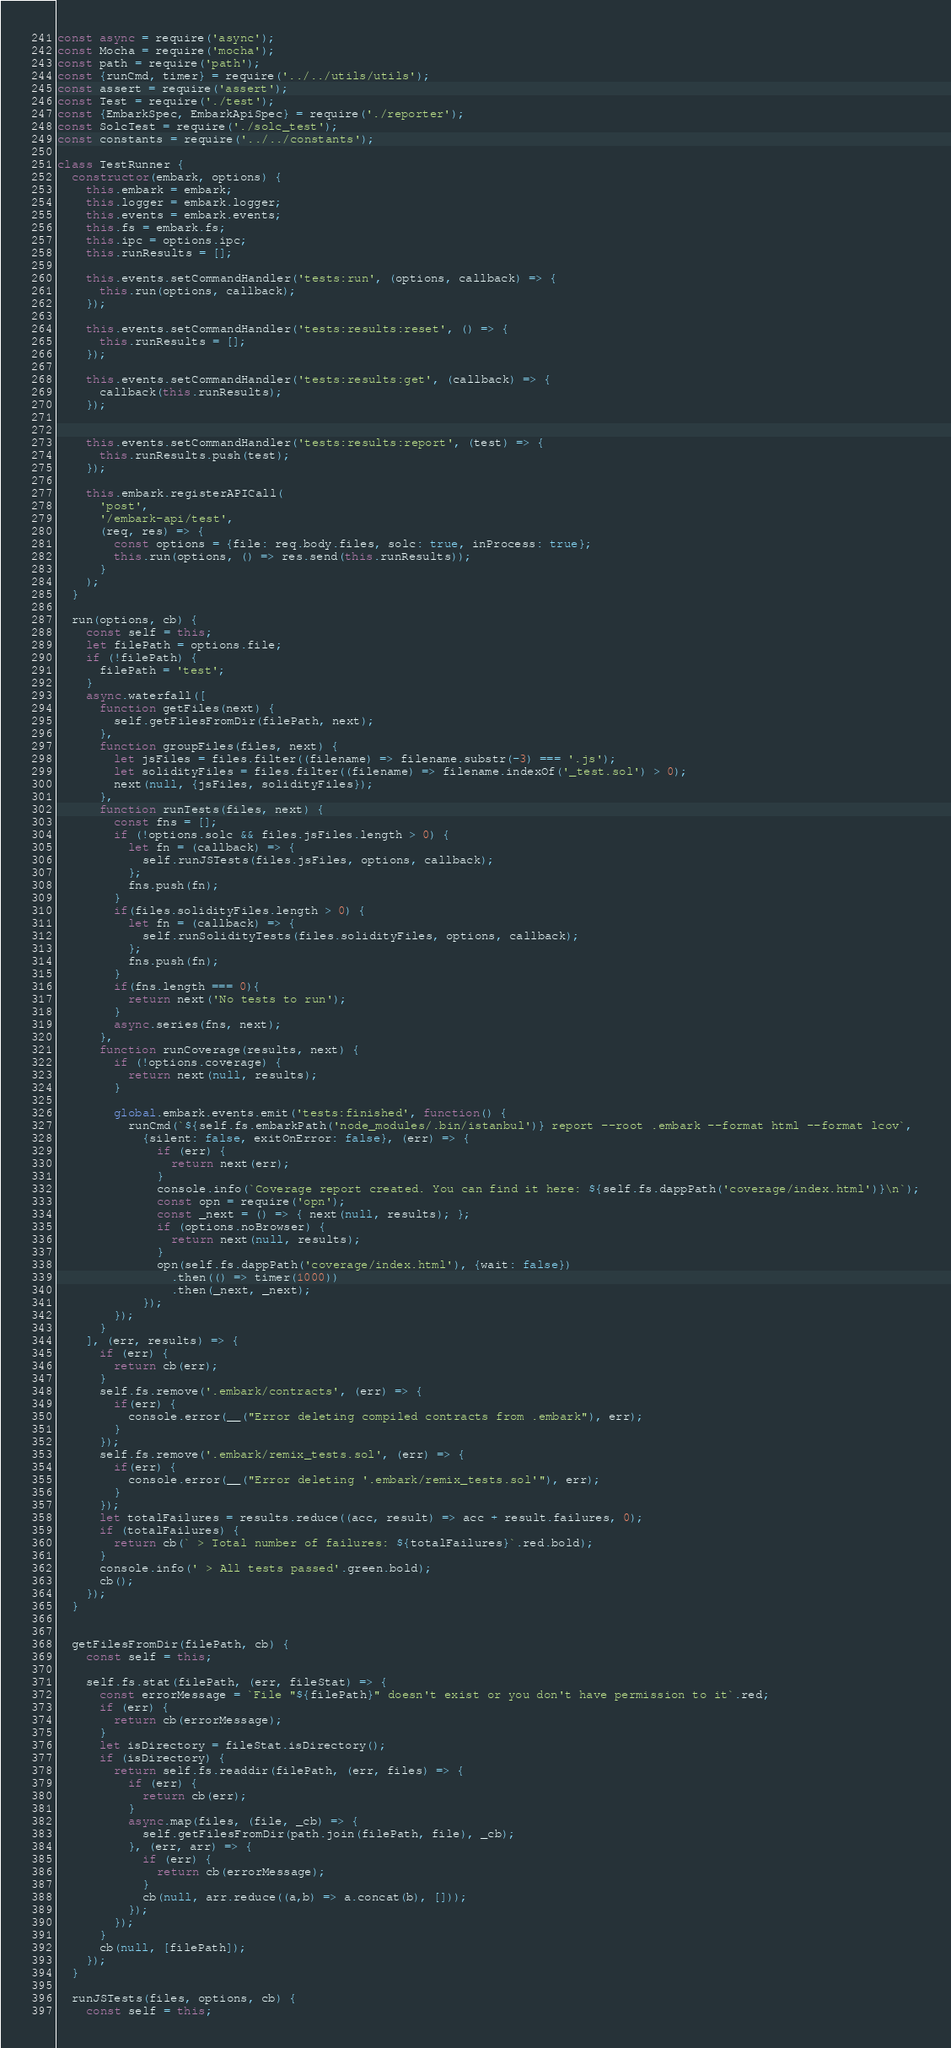<code> <loc_0><loc_0><loc_500><loc_500><_JavaScript_>const async = require('async');
const Mocha = require('mocha');
const path = require('path');
const {runCmd, timer} = require('../../utils/utils');
const assert = require('assert');
const Test = require('./test');
const {EmbarkSpec, EmbarkApiSpec} = require('./reporter');
const SolcTest = require('./solc_test');
const constants = require('../../constants');

class TestRunner {
  constructor(embark, options) {
    this.embark = embark;
    this.logger = embark.logger;
    this.events = embark.events;
    this.fs = embark.fs;
    this.ipc = options.ipc;
    this.runResults = [];

    this.events.setCommandHandler('tests:run', (options, callback) => {
      this.run(options, callback);
    });

    this.events.setCommandHandler('tests:results:reset', () => {
      this.runResults = [];
    });

    this.events.setCommandHandler('tests:results:get', (callback) => {
      callback(this.runResults);
    });


    this.events.setCommandHandler('tests:results:report', (test) => {
      this.runResults.push(test);
    });

    this.embark.registerAPICall(
      'post',
      '/embark-api/test',
      (req, res) => {
        const options = {file: req.body.files, solc: true, inProcess: true};
        this.run(options, () => res.send(this.runResults));
      }
    );
  }

  run(options, cb) {
    const self = this;
    let filePath = options.file;
    if (!filePath) {
      filePath = 'test';
    }
    async.waterfall([
      function getFiles(next) {
        self.getFilesFromDir(filePath, next);
      },
      function groupFiles(files, next) {
        let jsFiles = files.filter((filename) => filename.substr(-3) === '.js');
        let solidityFiles = files.filter((filename) => filename.indexOf('_test.sol') > 0);
        next(null, {jsFiles, solidityFiles});
      },
      function runTests(files, next) {
        const fns = [];
        if (!options.solc && files.jsFiles.length > 0) {
          let fn = (callback) => {
            self.runJSTests(files.jsFiles, options, callback);
          };
          fns.push(fn);
        }
        if(files.solidityFiles.length > 0) {
          let fn = (callback) => {
            self.runSolidityTests(files.solidityFiles, options, callback);
          };
          fns.push(fn);
        }
        if(fns.length === 0){
          return next('No tests to run');
        }
        async.series(fns, next);
      },
      function runCoverage(results, next) {
        if (!options.coverage) {
          return next(null, results);
        }

        global.embark.events.emit('tests:finished', function() {
          runCmd(`${self.fs.embarkPath('node_modules/.bin/istanbul')} report --root .embark --format html --format lcov`,
            {silent: false, exitOnError: false}, (err) => {
              if (err) {
                return next(err);
              }
              console.info(`Coverage report created. You can find it here: ${self.fs.dappPath('coverage/index.html')}\n`);
              const opn = require('opn');
              const _next = () => { next(null, results); };
              if (options.noBrowser) {
                return next(null, results);
              }
              opn(self.fs.dappPath('coverage/index.html'), {wait: false})
                .then(() => timer(1000))
                .then(_next, _next);
            });
        });
      }
    ], (err, results) => {
      if (err) {
        return cb(err);
      }
      self.fs.remove('.embark/contracts', (err) => {
        if(err) {
          console.error(__("Error deleting compiled contracts from .embark"), err);
        }
      });
      self.fs.remove('.embark/remix_tests.sol', (err) => {
        if(err) {
          console.error(__("Error deleting '.embark/remix_tests.sol'"), err);
        }
      });
      let totalFailures = results.reduce((acc, result) => acc + result.failures, 0);
      if (totalFailures) {
        return cb(` > Total number of failures: ${totalFailures}`.red.bold);
      }
      console.info(' > All tests passed'.green.bold);
      cb();
    });
  }


  getFilesFromDir(filePath, cb) {
    const self = this;

    self.fs.stat(filePath, (err, fileStat) => {
      const errorMessage = `File "${filePath}" doesn't exist or you don't have permission to it`.red;
      if (err) {
        return cb(errorMessage);
      }
      let isDirectory = fileStat.isDirectory();
      if (isDirectory) {
        return self.fs.readdir(filePath, (err, files) => {
          if (err) {
            return cb(err);
          }
          async.map(files, (file, _cb) => {
            self.getFilesFromDir(path.join(filePath, file), _cb);
          }, (err, arr) => {
            if (err) {
              return cb(errorMessage);
            }
            cb(null, arr.reduce((a,b) => a.concat(b), []));
          });
        });
      }
      cb(null, [filePath]);
    });
  }

  runJSTests(files, options, cb) {
    const self = this;</code> 